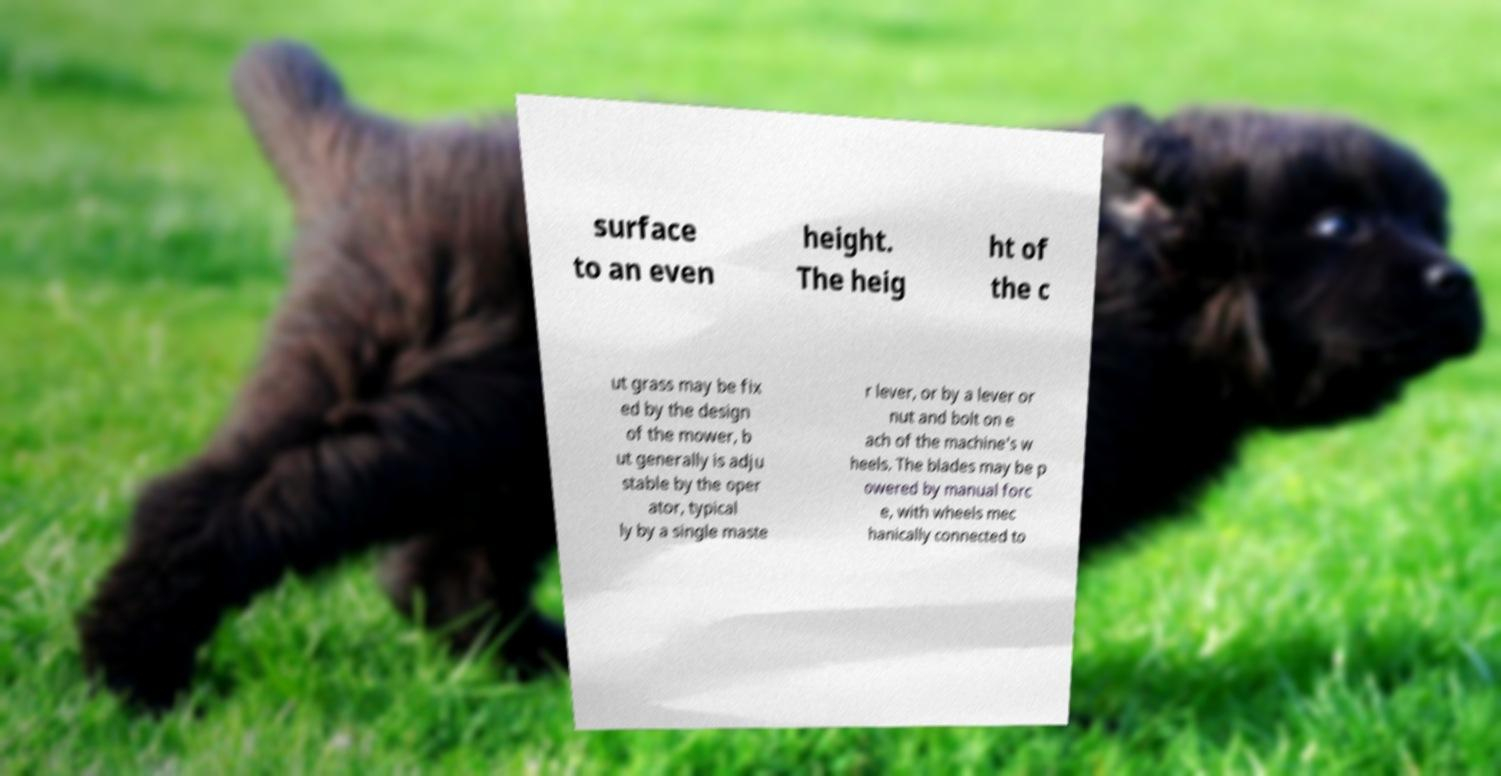What messages or text are displayed in this image? I need them in a readable, typed format. surface to an even height. The heig ht of the c ut grass may be fix ed by the design of the mower, b ut generally is adju stable by the oper ator, typical ly by a single maste r lever, or by a lever or nut and bolt on e ach of the machine's w heels. The blades may be p owered by manual forc e, with wheels mec hanically connected to 